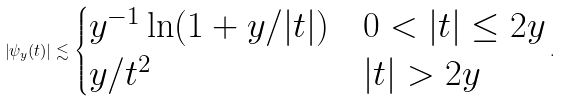<formula> <loc_0><loc_0><loc_500><loc_500>\left | \psi _ { y } ( t ) \right | \lesssim \begin{cases} y ^ { - 1 } \ln ( 1 + y / | t | ) & 0 < | t | \leq 2 y \\ y / t ^ { 2 } & | t | > 2 y \end{cases} .</formula> 